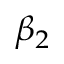<formula> <loc_0><loc_0><loc_500><loc_500>\beta _ { 2 }</formula> 